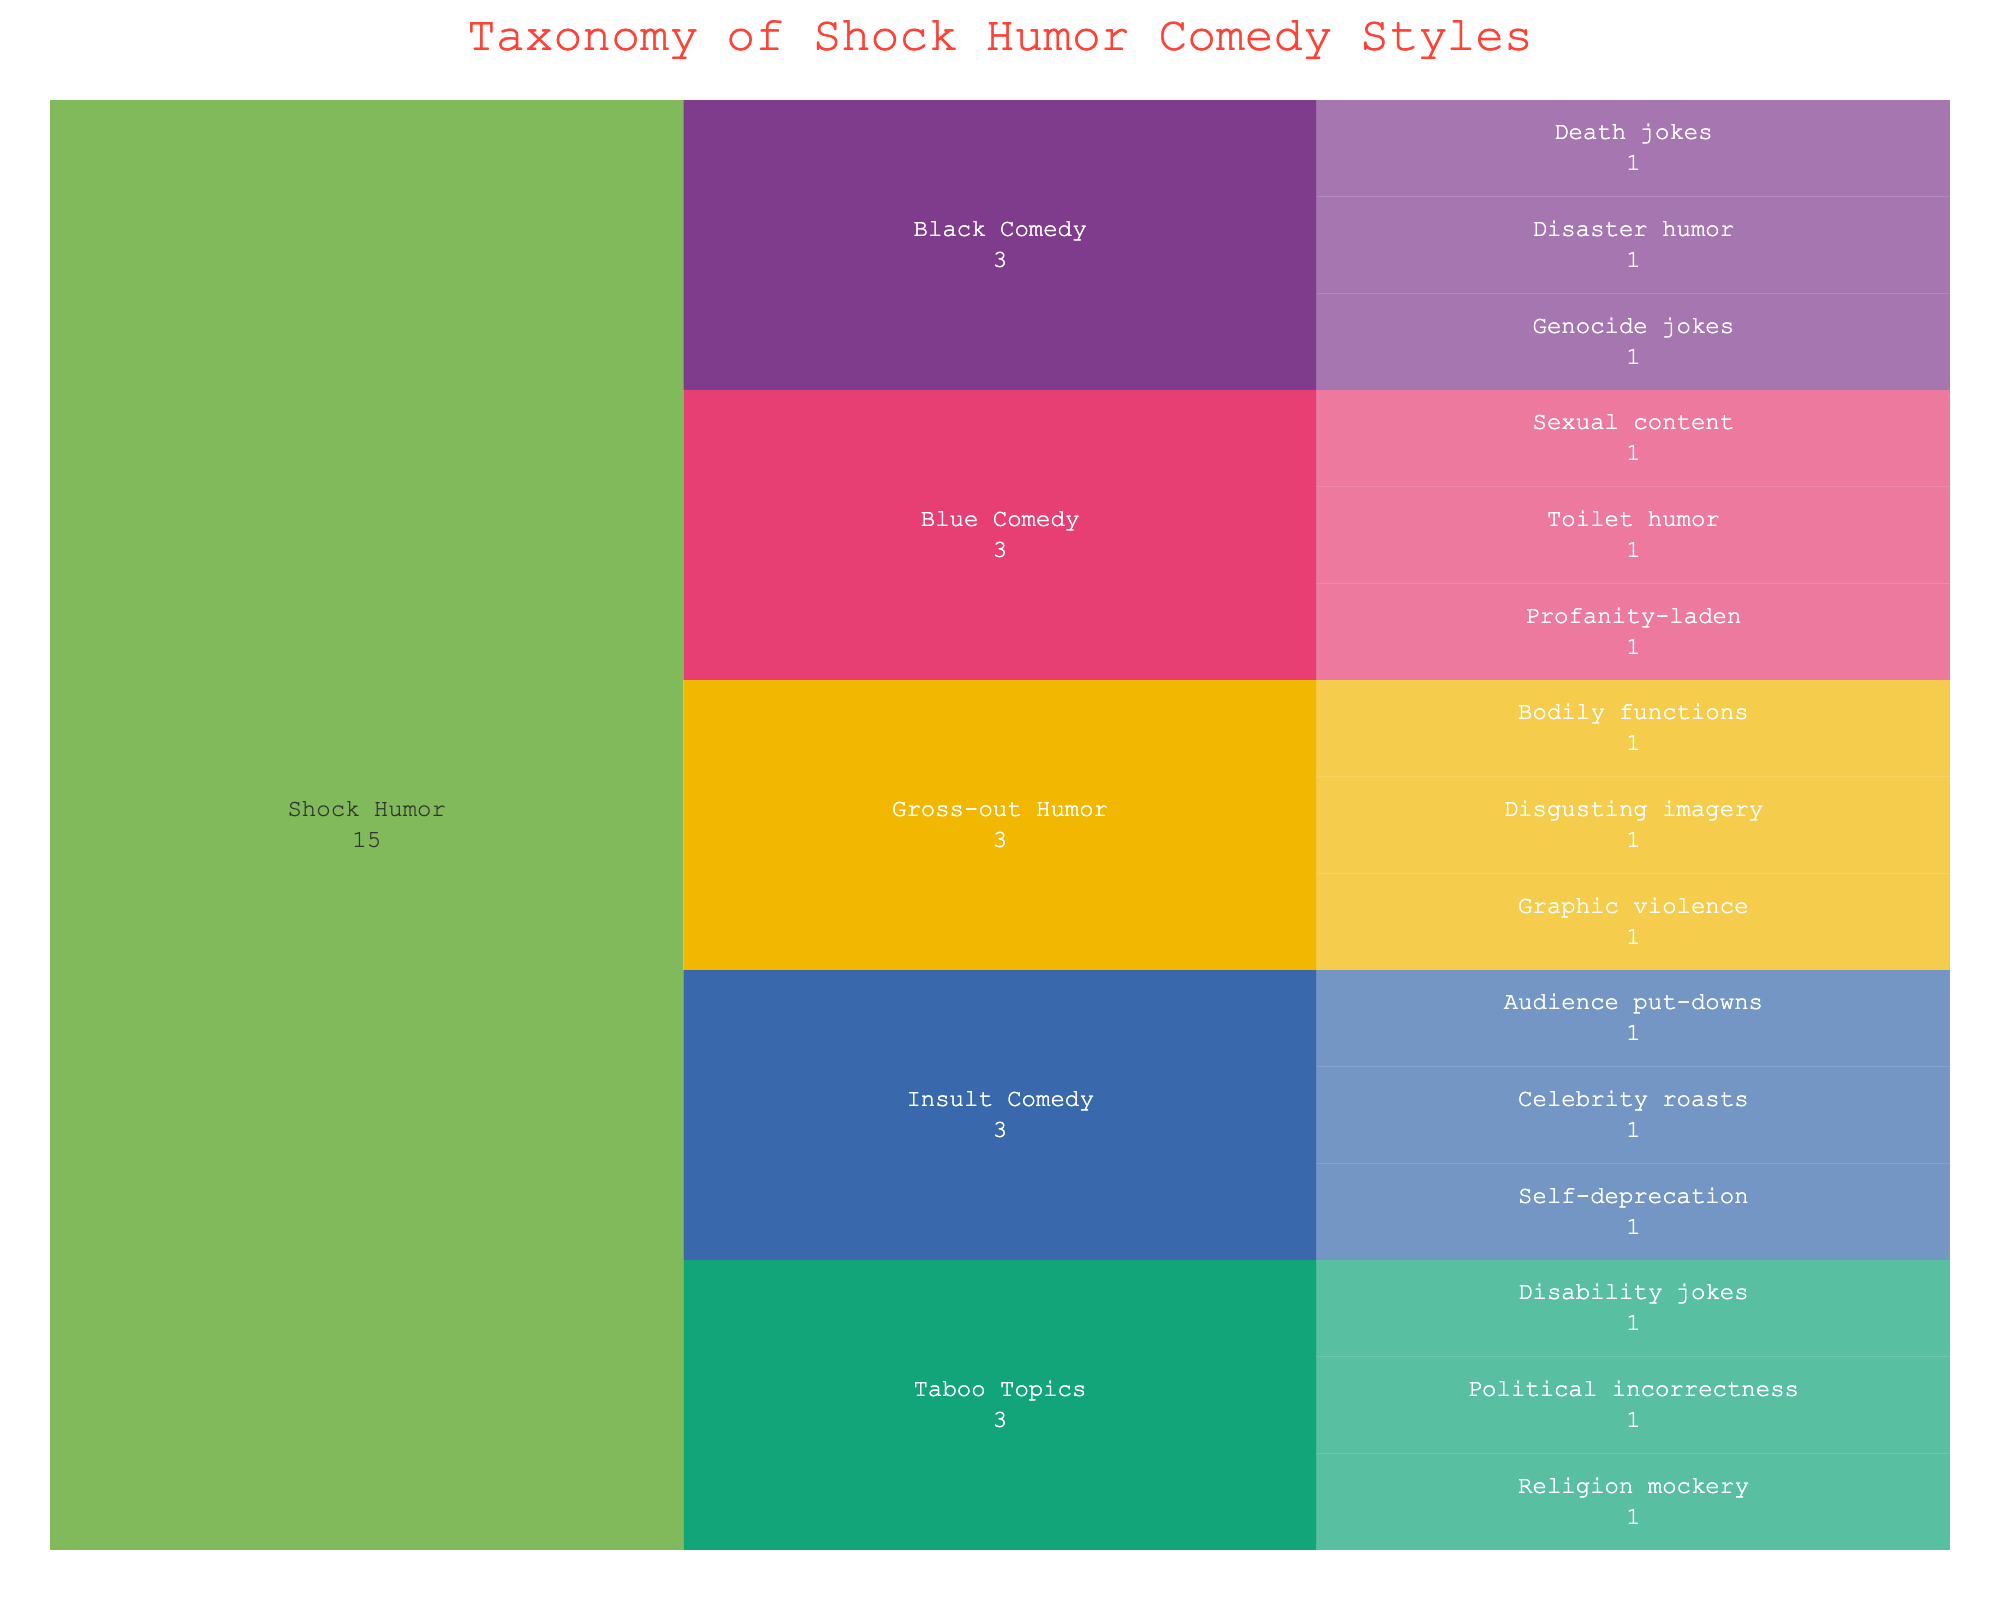What's the title of the Icicle Chart? The title of the icicle chart is displayed prominent at the top center of the figure.
Answer: Taxonomy of Shock Humor Comedy Styles How many subcategories are there under "Shock Humor"? To find the number of subcategories under "Shock Humor," count all unique subcategory names directly beneath the "Shock Humor" category.
Answer: 4 Which subcategory has the most styles listed? To determine which subcategory has the most styles, count the number of styles under each subcategory and identify the one with the maximum count.
Answer: Blue Comedy How does the number of styles compare between "Insult Comedy" and "Gross-out Humor"? First, count the number of styles under "Insult Comedy" and then count the number under "Gross-out Humor". Compare these counts to see which has more.
Answer: Insult Comedy has one less style than Gross-out Humor What are the styles listed under "Black Comedy"? Look under "Black Comedy" to find all the styles that fall under this subcategory.
Answer: Death jokes, Disaster humor, Genocide jokes Which style belongs to both "Taboo Topics" and contains religious context? Look within the "Taboo Topics" subcategory for any style that mentioned or mocks religion.
Answer: Religion mockery What is the relationship between "Taboo Topics" and "Black Comedy" in terms of the number of styles? Count the number of styles in both subcategories "Taboo Topics" and "Black Comedy" and compare these numbers.
Answer: Taboo Topics and Black Comedy both have 3 styles each Identify the subcategory and style related to "celebrity" in "Shock Humor". Scan through the "Shock Humor" category for the keyword "celebrity" within any subcategory and style listings.
Answer: Insult Comedy, Celebrity roasts How many styles fall under subcategories that deal with physical or bodily aspects? Identify styles across subcategories that deal with physical or bodily aspects like "Gross-out Humor" and "Toilet humor" under "Blue Comedy." Sum these numbers.
Answer: 6 How can the diversity of comedy styles under "Shock Humor" help appeal to different audience preferences? Analyze how the variety of subcategories (like profanity, death, and bodily functions) covers a wide spectrum of humor elements, appealing to different tastes. This requires synthesizing the variation and application's logical reasoning.
Answer: It provides a wide range of controversial and taboo topics that can attract different audience groups looking for edgy humor 